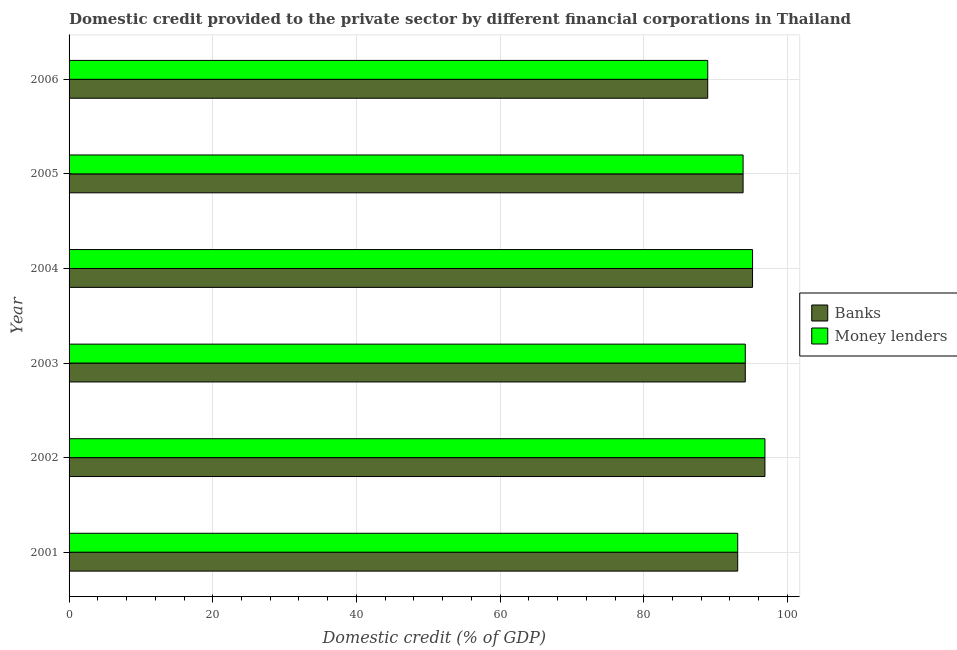Are the number of bars on each tick of the Y-axis equal?
Provide a succinct answer. Yes. How many bars are there on the 5th tick from the top?
Provide a succinct answer. 2. What is the label of the 2nd group of bars from the top?
Your answer should be very brief. 2005. What is the domestic credit provided by banks in 2004?
Provide a short and direct response. 95.14. Across all years, what is the maximum domestic credit provided by money lenders?
Your answer should be very brief. 96.87. Across all years, what is the minimum domestic credit provided by money lenders?
Your answer should be compact. 88.91. In which year was the domestic credit provided by money lenders maximum?
Ensure brevity in your answer.  2002. In which year was the domestic credit provided by banks minimum?
Keep it short and to the point. 2006. What is the total domestic credit provided by banks in the graph?
Ensure brevity in your answer.  561.96. What is the difference between the domestic credit provided by banks in 2001 and that in 2003?
Ensure brevity in your answer.  -1.06. What is the difference between the domestic credit provided by money lenders in 2004 and the domestic credit provided by banks in 2001?
Your response must be concise. 2.07. What is the average domestic credit provided by money lenders per year?
Your answer should be compact. 93.66. In the year 2005, what is the difference between the domestic credit provided by money lenders and domestic credit provided by banks?
Make the answer very short. 0. Is the domestic credit provided by money lenders in 2001 less than that in 2003?
Give a very brief answer. Yes. What is the difference between the highest and the second highest domestic credit provided by banks?
Your answer should be very brief. 1.73. What is the difference between the highest and the lowest domestic credit provided by money lenders?
Keep it short and to the point. 7.96. Is the sum of the domestic credit provided by money lenders in 2001 and 2005 greater than the maximum domestic credit provided by banks across all years?
Ensure brevity in your answer.  Yes. What does the 1st bar from the top in 2003 represents?
Make the answer very short. Money lenders. What does the 1st bar from the bottom in 2002 represents?
Provide a succinct answer. Banks. What is the difference between two consecutive major ticks on the X-axis?
Provide a short and direct response. 20. Where does the legend appear in the graph?
Offer a terse response. Center right. How are the legend labels stacked?
Offer a terse response. Vertical. What is the title of the graph?
Keep it short and to the point. Domestic credit provided to the private sector by different financial corporations in Thailand. Does "Largest city" appear as one of the legend labels in the graph?
Provide a short and direct response. No. What is the label or title of the X-axis?
Your answer should be compact. Domestic credit (% of GDP). What is the Domestic credit (% of GDP) of Banks in 2001?
Give a very brief answer. 93.08. What is the Domestic credit (% of GDP) of Money lenders in 2001?
Your answer should be very brief. 93.08. What is the Domestic credit (% of GDP) of Banks in 2002?
Offer a very short reply. 96.87. What is the Domestic credit (% of GDP) of Money lenders in 2002?
Provide a succinct answer. 96.87. What is the Domestic credit (% of GDP) in Banks in 2003?
Ensure brevity in your answer.  94.13. What is the Domestic credit (% of GDP) of Money lenders in 2003?
Keep it short and to the point. 94.13. What is the Domestic credit (% of GDP) in Banks in 2004?
Your response must be concise. 95.14. What is the Domestic credit (% of GDP) in Money lenders in 2004?
Provide a short and direct response. 95.14. What is the Domestic credit (% of GDP) of Banks in 2005?
Offer a terse response. 93.83. What is the Domestic credit (% of GDP) in Money lenders in 2005?
Offer a terse response. 93.83. What is the Domestic credit (% of GDP) of Banks in 2006?
Ensure brevity in your answer.  88.91. What is the Domestic credit (% of GDP) of Money lenders in 2006?
Give a very brief answer. 88.91. Across all years, what is the maximum Domestic credit (% of GDP) in Banks?
Ensure brevity in your answer.  96.87. Across all years, what is the maximum Domestic credit (% of GDP) of Money lenders?
Keep it short and to the point. 96.87. Across all years, what is the minimum Domestic credit (% of GDP) of Banks?
Provide a short and direct response. 88.91. Across all years, what is the minimum Domestic credit (% of GDP) of Money lenders?
Provide a succinct answer. 88.91. What is the total Domestic credit (% of GDP) in Banks in the graph?
Ensure brevity in your answer.  561.96. What is the total Domestic credit (% of GDP) in Money lenders in the graph?
Keep it short and to the point. 561.96. What is the difference between the Domestic credit (% of GDP) in Banks in 2001 and that in 2002?
Offer a very short reply. -3.79. What is the difference between the Domestic credit (% of GDP) of Money lenders in 2001 and that in 2002?
Provide a succinct answer. -3.79. What is the difference between the Domestic credit (% of GDP) of Banks in 2001 and that in 2003?
Provide a short and direct response. -1.06. What is the difference between the Domestic credit (% of GDP) of Money lenders in 2001 and that in 2003?
Give a very brief answer. -1.06. What is the difference between the Domestic credit (% of GDP) in Banks in 2001 and that in 2004?
Make the answer very short. -2.06. What is the difference between the Domestic credit (% of GDP) in Money lenders in 2001 and that in 2004?
Give a very brief answer. -2.07. What is the difference between the Domestic credit (% of GDP) in Banks in 2001 and that in 2005?
Keep it short and to the point. -0.75. What is the difference between the Domestic credit (% of GDP) in Money lenders in 2001 and that in 2005?
Offer a very short reply. -0.75. What is the difference between the Domestic credit (% of GDP) in Banks in 2001 and that in 2006?
Offer a very short reply. 4.17. What is the difference between the Domestic credit (% of GDP) of Money lenders in 2001 and that in 2006?
Offer a terse response. 4.17. What is the difference between the Domestic credit (% of GDP) of Banks in 2002 and that in 2003?
Provide a succinct answer. 2.73. What is the difference between the Domestic credit (% of GDP) in Money lenders in 2002 and that in 2003?
Offer a very short reply. 2.73. What is the difference between the Domestic credit (% of GDP) in Banks in 2002 and that in 2004?
Your response must be concise. 1.73. What is the difference between the Domestic credit (% of GDP) of Money lenders in 2002 and that in 2004?
Your answer should be compact. 1.72. What is the difference between the Domestic credit (% of GDP) in Banks in 2002 and that in 2005?
Your answer should be very brief. 3.04. What is the difference between the Domestic credit (% of GDP) in Money lenders in 2002 and that in 2005?
Offer a very short reply. 3.04. What is the difference between the Domestic credit (% of GDP) of Banks in 2002 and that in 2006?
Your answer should be compact. 7.96. What is the difference between the Domestic credit (% of GDP) in Money lenders in 2002 and that in 2006?
Make the answer very short. 7.96. What is the difference between the Domestic credit (% of GDP) in Banks in 2003 and that in 2004?
Your answer should be very brief. -1.01. What is the difference between the Domestic credit (% of GDP) of Money lenders in 2003 and that in 2004?
Provide a succinct answer. -1.01. What is the difference between the Domestic credit (% of GDP) of Banks in 2003 and that in 2005?
Make the answer very short. 0.31. What is the difference between the Domestic credit (% of GDP) in Money lenders in 2003 and that in 2005?
Provide a succinct answer. 0.3. What is the difference between the Domestic credit (% of GDP) in Banks in 2003 and that in 2006?
Offer a very short reply. 5.23. What is the difference between the Domestic credit (% of GDP) of Money lenders in 2003 and that in 2006?
Your answer should be compact. 5.23. What is the difference between the Domestic credit (% of GDP) of Banks in 2004 and that in 2005?
Provide a short and direct response. 1.31. What is the difference between the Domestic credit (% of GDP) in Money lenders in 2004 and that in 2005?
Provide a succinct answer. 1.31. What is the difference between the Domestic credit (% of GDP) of Banks in 2004 and that in 2006?
Keep it short and to the point. 6.24. What is the difference between the Domestic credit (% of GDP) of Money lenders in 2004 and that in 2006?
Ensure brevity in your answer.  6.24. What is the difference between the Domestic credit (% of GDP) in Banks in 2005 and that in 2006?
Your answer should be compact. 4.92. What is the difference between the Domestic credit (% of GDP) of Money lenders in 2005 and that in 2006?
Offer a terse response. 4.92. What is the difference between the Domestic credit (% of GDP) of Banks in 2001 and the Domestic credit (% of GDP) of Money lenders in 2002?
Make the answer very short. -3.79. What is the difference between the Domestic credit (% of GDP) of Banks in 2001 and the Domestic credit (% of GDP) of Money lenders in 2003?
Give a very brief answer. -1.06. What is the difference between the Domestic credit (% of GDP) of Banks in 2001 and the Domestic credit (% of GDP) of Money lenders in 2004?
Your answer should be very brief. -2.07. What is the difference between the Domestic credit (% of GDP) of Banks in 2001 and the Domestic credit (% of GDP) of Money lenders in 2005?
Provide a succinct answer. -0.75. What is the difference between the Domestic credit (% of GDP) in Banks in 2001 and the Domestic credit (% of GDP) in Money lenders in 2006?
Keep it short and to the point. 4.17. What is the difference between the Domestic credit (% of GDP) of Banks in 2002 and the Domestic credit (% of GDP) of Money lenders in 2003?
Make the answer very short. 2.73. What is the difference between the Domestic credit (% of GDP) of Banks in 2002 and the Domestic credit (% of GDP) of Money lenders in 2004?
Offer a terse response. 1.72. What is the difference between the Domestic credit (% of GDP) in Banks in 2002 and the Domestic credit (% of GDP) in Money lenders in 2005?
Provide a short and direct response. 3.04. What is the difference between the Domestic credit (% of GDP) of Banks in 2002 and the Domestic credit (% of GDP) of Money lenders in 2006?
Keep it short and to the point. 7.96. What is the difference between the Domestic credit (% of GDP) in Banks in 2003 and the Domestic credit (% of GDP) in Money lenders in 2004?
Your answer should be compact. -1.01. What is the difference between the Domestic credit (% of GDP) in Banks in 2003 and the Domestic credit (% of GDP) in Money lenders in 2005?
Keep it short and to the point. 0.3. What is the difference between the Domestic credit (% of GDP) of Banks in 2003 and the Domestic credit (% of GDP) of Money lenders in 2006?
Ensure brevity in your answer.  5.23. What is the difference between the Domestic credit (% of GDP) of Banks in 2004 and the Domestic credit (% of GDP) of Money lenders in 2005?
Keep it short and to the point. 1.31. What is the difference between the Domestic credit (% of GDP) of Banks in 2004 and the Domestic credit (% of GDP) of Money lenders in 2006?
Keep it short and to the point. 6.24. What is the difference between the Domestic credit (% of GDP) of Banks in 2005 and the Domestic credit (% of GDP) of Money lenders in 2006?
Provide a succinct answer. 4.92. What is the average Domestic credit (% of GDP) of Banks per year?
Give a very brief answer. 93.66. What is the average Domestic credit (% of GDP) of Money lenders per year?
Your response must be concise. 93.66. In the year 2002, what is the difference between the Domestic credit (% of GDP) in Banks and Domestic credit (% of GDP) in Money lenders?
Offer a terse response. 0. In the year 2003, what is the difference between the Domestic credit (% of GDP) of Banks and Domestic credit (% of GDP) of Money lenders?
Make the answer very short. -0. In the year 2004, what is the difference between the Domestic credit (% of GDP) of Banks and Domestic credit (% of GDP) of Money lenders?
Provide a succinct answer. -0. In the year 2005, what is the difference between the Domestic credit (% of GDP) in Banks and Domestic credit (% of GDP) in Money lenders?
Offer a terse response. -0. In the year 2006, what is the difference between the Domestic credit (% of GDP) of Banks and Domestic credit (% of GDP) of Money lenders?
Your response must be concise. -0. What is the ratio of the Domestic credit (% of GDP) of Banks in 2001 to that in 2002?
Provide a short and direct response. 0.96. What is the ratio of the Domestic credit (% of GDP) in Money lenders in 2001 to that in 2002?
Provide a succinct answer. 0.96. What is the ratio of the Domestic credit (% of GDP) of Banks in 2001 to that in 2004?
Keep it short and to the point. 0.98. What is the ratio of the Domestic credit (% of GDP) in Money lenders in 2001 to that in 2004?
Keep it short and to the point. 0.98. What is the ratio of the Domestic credit (% of GDP) in Banks in 2001 to that in 2005?
Your response must be concise. 0.99. What is the ratio of the Domestic credit (% of GDP) of Banks in 2001 to that in 2006?
Keep it short and to the point. 1.05. What is the ratio of the Domestic credit (% of GDP) in Money lenders in 2001 to that in 2006?
Your answer should be very brief. 1.05. What is the ratio of the Domestic credit (% of GDP) in Banks in 2002 to that in 2003?
Provide a succinct answer. 1.03. What is the ratio of the Domestic credit (% of GDP) in Money lenders in 2002 to that in 2003?
Your answer should be compact. 1.03. What is the ratio of the Domestic credit (% of GDP) in Banks in 2002 to that in 2004?
Ensure brevity in your answer.  1.02. What is the ratio of the Domestic credit (% of GDP) in Money lenders in 2002 to that in 2004?
Your answer should be compact. 1.02. What is the ratio of the Domestic credit (% of GDP) of Banks in 2002 to that in 2005?
Offer a terse response. 1.03. What is the ratio of the Domestic credit (% of GDP) of Money lenders in 2002 to that in 2005?
Your answer should be very brief. 1.03. What is the ratio of the Domestic credit (% of GDP) of Banks in 2002 to that in 2006?
Ensure brevity in your answer.  1.09. What is the ratio of the Domestic credit (% of GDP) in Money lenders in 2002 to that in 2006?
Your response must be concise. 1.09. What is the ratio of the Domestic credit (% of GDP) of Money lenders in 2003 to that in 2004?
Keep it short and to the point. 0.99. What is the ratio of the Domestic credit (% of GDP) of Banks in 2003 to that in 2005?
Keep it short and to the point. 1. What is the ratio of the Domestic credit (% of GDP) of Banks in 2003 to that in 2006?
Keep it short and to the point. 1.06. What is the ratio of the Domestic credit (% of GDP) in Money lenders in 2003 to that in 2006?
Make the answer very short. 1.06. What is the ratio of the Domestic credit (% of GDP) in Banks in 2004 to that in 2005?
Your answer should be compact. 1.01. What is the ratio of the Domestic credit (% of GDP) in Money lenders in 2004 to that in 2005?
Ensure brevity in your answer.  1.01. What is the ratio of the Domestic credit (% of GDP) in Banks in 2004 to that in 2006?
Provide a short and direct response. 1.07. What is the ratio of the Domestic credit (% of GDP) of Money lenders in 2004 to that in 2006?
Provide a short and direct response. 1.07. What is the ratio of the Domestic credit (% of GDP) in Banks in 2005 to that in 2006?
Give a very brief answer. 1.06. What is the ratio of the Domestic credit (% of GDP) in Money lenders in 2005 to that in 2006?
Ensure brevity in your answer.  1.06. What is the difference between the highest and the second highest Domestic credit (% of GDP) in Banks?
Provide a short and direct response. 1.73. What is the difference between the highest and the second highest Domestic credit (% of GDP) in Money lenders?
Make the answer very short. 1.72. What is the difference between the highest and the lowest Domestic credit (% of GDP) of Banks?
Your answer should be very brief. 7.96. What is the difference between the highest and the lowest Domestic credit (% of GDP) in Money lenders?
Provide a short and direct response. 7.96. 